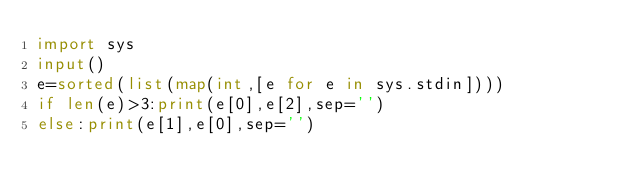<code> <loc_0><loc_0><loc_500><loc_500><_Python_>import sys
input()
e=sorted(list(map(int,[e for e in sys.stdin])))
if len(e)>3:print(e[0],e[2],sep='')
else:print(e[1],e[0],sep='')
</code> 